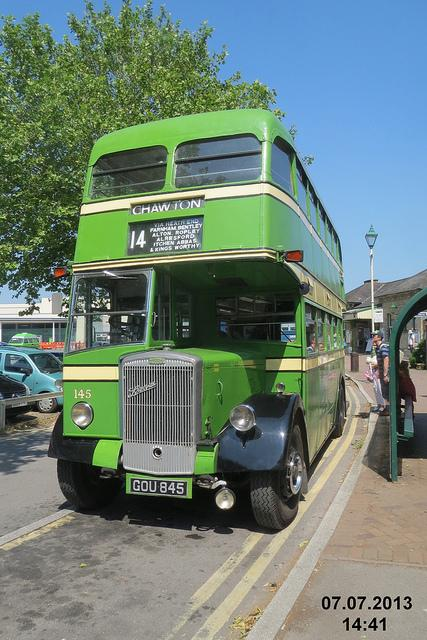In which country does this bus travel? england 